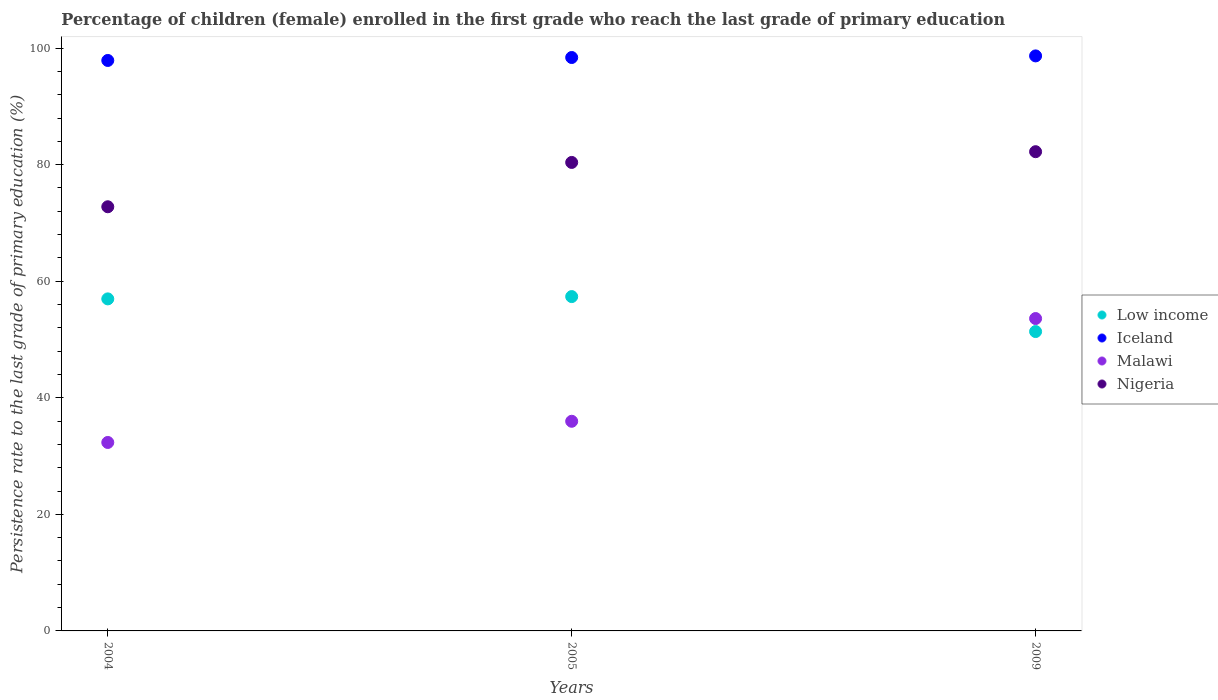How many different coloured dotlines are there?
Keep it short and to the point. 4. Is the number of dotlines equal to the number of legend labels?
Ensure brevity in your answer.  Yes. What is the persistence rate of children in Iceland in 2009?
Ensure brevity in your answer.  98.65. Across all years, what is the maximum persistence rate of children in Iceland?
Offer a very short reply. 98.65. Across all years, what is the minimum persistence rate of children in Malawi?
Your answer should be very brief. 32.33. In which year was the persistence rate of children in Malawi maximum?
Your answer should be compact. 2009. In which year was the persistence rate of children in Low income minimum?
Your answer should be compact. 2009. What is the total persistence rate of children in Low income in the graph?
Offer a terse response. 165.69. What is the difference between the persistence rate of children in Malawi in 2004 and that in 2005?
Your answer should be compact. -3.63. What is the difference between the persistence rate of children in Low income in 2005 and the persistence rate of children in Malawi in 2009?
Ensure brevity in your answer.  3.77. What is the average persistence rate of children in Low income per year?
Provide a succinct answer. 55.23. In the year 2004, what is the difference between the persistence rate of children in Low income and persistence rate of children in Iceland?
Give a very brief answer. -40.91. In how many years, is the persistence rate of children in Low income greater than 36 %?
Provide a short and direct response. 3. What is the ratio of the persistence rate of children in Iceland in 2004 to that in 2009?
Your response must be concise. 0.99. Is the persistence rate of children in Low income in 2004 less than that in 2005?
Your answer should be very brief. Yes. Is the difference between the persistence rate of children in Low income in 2004 and 2009 greater than the difference between the persistence rate of children in Iceland in 2004 and 2009?
Offer a very short reply. Yes. What is the difference between the highest and the second highest persistence rate of children in Iceland?
Ensure brevity in your answer.  0.27. What is the difference between the highest and the lowest persistence rate of children in Nigeria?
Keep it short and to the point. 9.45. In how many years, is the persistence rate of children in Low income greater than the average persistence rate of children in Low income taken over all years?
Keep it short and to the point. 2. Is it the case that in every year, the sum of the persistence rate of children in Iceland and persistence rate of children in Low income  is greater than the sum of persistence rate of children in Nigeria and persistence rate of children in Malawi?
Provide a short and direct response. No. Is the persistence rate of children in Low income strictly greater than the persistence rate of children in Malawi over the years?
Your answer should be compact. No. Is the persistence rate of children in Nigeria strictly less than the persistence rate of children in Low income over the years?
Your response must be concise. No. How many years are there in the graph?
Provide a succinct answer. 3. Does the graph contain any zero values?
Provide a succinct answer. No. Does the graph contain grids?
Ensure brevity in your answer.  No. What is the title of the graph?
Your answer should be compact. Percentage of children (female) enrolled in the first grade who reach the last grade of primary education. What is the label or title of the X-axis?
Your answer should be very brief. Years. What is the label or title of the Y-axis?
Keep it short and to the point. Persistence rate to the last grade of primary education (%). What is the Persistence rate to the last grade of primary education (%) of Low income in 2004?
Your response must be concise. 56.97. What is the Persistence rate to the last grade of primary education (%) of Iceland in 2004?
Offer a very short reply. 97.87. What is the Persistence rate to the last grade of primary education (%) in Malawi in 2004?
Your response must be concise. 32.33. What is the Persistence rate to the last grade of primary education (%) of Nigeria in 2004?
Keep it short and to the point. 72.77. What is the Persistence rate to the last grade of primary education (%) of Low income in 2005?
Make the answer very short. 57.36. What is the Persistence rate to the last grade of primary education (%) of Iceland in 2005?
Keep it short and to the point. 98.38. What is the Persistence rate to the last grade of primary education (%) of Malawi in 2005?
Your answer should be compact. 35.97. What is the Persistence rate to the last grade of primary education (%) of Nigeria in 2005?
Ensure brevity in your answer.  80.38. What is the Persistence rate to the last grade of primary education (%) in Low income in 2009?
Ensure brevity in your answer.  51.36. What is the Persistence rate to the last grade of primary education (%) in Iceland in 2009?
Make the answer very short. 98.65. What is the Persistence rate to the last grade of primary education (%) in Malawi in 2009?
Your response must be concise. 53.59. What is the Persistence rate to the last grade of primary education (%) of Nigeria in 2009?
Make the answer very short. 82.22. Across all years, what is the maximum Persistence rate to the last grade of primary education (%) of Low income?
Offer a very short reply. 57.36. Across all years, what is the maximum Persistence rate to the last grade of primary education (%) in Iceland?
Your answer should be very brief. 98.65. Across all years, what is the maximum Persistence rate to the last grade of primary education (%) of Malawi?
Keep it short and to the point. 53.59. Across all years, what is the maximum Persistence rate to the last grade of primary education (%) in Nigeria?
Ensure brevity in your answer.  82.22. Across all years, what is the minimum Persistence rate to the last grade of primary education (%) in Low income?
Your response must be concise. 51.36. Across all years, what is the minimum Persistence rate to the last grade of primary education (%) of Iceland?
Ensure brevity in your answer.  97.87. Across all years, what is the minimum Persistence rate to the last grade of primary education (%) of Malawi?
Your answer should be compact. 32.33. Across all years, what is the minimum Persistence rate to the last grade of primary education (%) in Nigeria?
Your answer should be very brief. 72.77. What is the total Persistence rate to the last grade of primary education (%) in Low income in the graph?
Your answer should be compact. 165.69. What is the total Persistence rate to the last grade of primary education (%) of Iceland in the graph?
Make the answer very short. 294.91. What is the total Persistence rate to the last grade of primary education (%) in Malawi in the graph?
Make the answer very short. 121.9. What is the total Persistence rate to the last grade of primary education (%) in Nigeria in the graph?
Offer a very short reply. 235.37. What is the difference between the Persistence rate to the last grade of primary education (%) in Low income in 2004 and that in 2005?
Your answer should be compact. -0.39. What is the difference between the Persistence rate to the last grade of primary education (%) of Iceland in 2004 and that in 2005?
Offer a very short reply. -0.51. What is the difference between the Persistence rate to the last grade of primary education (%) of Malawi in 2004 and that in 2005?
Give a very brief answer. -3.63. What is the difference between the Persistence rate to the last grade of primary education (%) in Nigeria in 2004 and that in 2005?
Offer a very short reply. -7.61. What is the difference between the Persistence rate to the last grade of primary education (%) of Low income in 2004 and that in 2009?
Provide a succinct answer. 5.61. What is the difference between the Persistence rate to the last grade of primary education (%) of Iceland in 2004 and that in 2009?
Offer a terse response. -0.78. What is the difference between the Persistence rate to the last grade of primary education (%) in Malawi in 2004 and that in 2009?
Offer a very short reply. -21.26. What is the difference between the Persistence rate to the last grade of primary education (%) in Nigeria in 2004 and that in 2009?
Keep it short and to the point. -9.45. What is the difference between the Persistence rate to the last grade of primary education (%) in Low income in 2005 and that in 2009?
Your answer should be compact. 6. What is the difference between the Persistence rate to the last grade of primary education (%) in Iceland in 2005 and that in 2009?
Your response must be concise. -0.27. What is the difference between the Persistence rate to the last grade of primary education (%) in Malawi in 2005 and that in 2009?
Offer a terse response. -17.63. What is the difference between the Persistence rate to the last grade of primary education (%) in Nigeria in 2005 and that in 2009?
Offer a terse response. -1.84. What is the difference between the Persistence rate to the last grade of primary education (%) of Low income in 2004 and the Persistence rate to the last grade of primary education (%) of Iceland in 2005?
Your response must be concise. -41.41. What is the difference between the Persistence rate to the last grade of primary education (%) of Low income in 2004 and the Persistence rate to the last grade of primary education (%) of Malawi in 2005?
Keep it short and to the point. 21. What is the difference between the Persistence rate to the last grade of primary education (%) of Low income in 2004 and the Persistence rate to the last grade of primary education (%) of Nigeria in 2005?
Make the answer very short. -23.41. What is the difference between the Persistence rate to the last grade of primary education (%) in Iceland in 2004 and the Persistence rate to the last grade of primary education (%) in Malawi in 2005?
Provide a succinct answer. 61.9. What is the difference between the Persistence rate to the last grade of primary education (%) of Iceland in 2004 and the Persistence rate to the last grade of primary education (%) of Nigeria in 2005?
Offer a terse response. 17.5. What is the difference between the Persistence rate to the last grade of primary education (%) in Malawi in 2004 and the Persistence rate to the last grade of primary education (%) in Nigeria in 2005?
Give a very brief answer. -48.04. What is the difference between the Persistence rate to the last grade of primary education (%) of Low income in 2004 and the Persistence rate to the last grade of primary education (%) of Iceland in 2009?
Provide a short and direct response. -41.69. What is the difference between the Persistence rate to the last grade of primary education (%) of Low income in 2004 and the Persistence rate to the last grade of primary education (%) of Malawi in 2009?
Provide a short and direct response. 3.37. What is the difference between the Persistence rate to the last grade of primary education (%) in Low income in 2004 and the Persistence rate to the last grade of primary education (%) in Nigeria in 2009?
Provide a succinct answer. -25.25. What is the difference between the Persistence rate to the last grade of primary education (%) in Iceland in 2004 and the Persistence rate to the last grade of primary education (%) in Malawi in 2009?
Offer a terse response. 44.28. What is the difference between the Persistence rate to the last grade of primary education (%) of Iceland in 2004 and the Persistence rate to the last grade of primary education (%) of Nigeria in 2009?
Offer a very short reply. 15.65. What is the difference between the Persistence rate to the last grade of primary education (%) of Malawi in 2004 and the Persistence rate to the last grade of primary education (%) of Nigeria in 2009?
Give a very brief answer. -49.89. What is the difference between the Persistence rate to the last grade of primary education (%) of Low income in 2005 and the Persistence rate to the last grade of primary education (%) of Iceland in 2009?
Keep it short and to the point. -41.29. What is the difference between the Persistence rate to the last grade of primary education (%) of Low income in 2005 and the Persistence rate to the last grade of primary education (%) of Malawi in 2009?
Keep it short and to the point. 3.77. What is the difference between the Persistence rate to the last grade of primary education (%) in Low income in 2005 and the Persistence rate to the last grade of primary education (%) in Nigeria in 2009?
Your answer should be very brief. -24.86. What is the difference between the Persistence rate to the last grade of primary education (%) of Iceland in 2005 and the Persistence rate to the last grade of primary education (%) of Malawi in 2009?
Provide a succinct answer. 44.78. What is the difference between the Persistence rate to the last grade of primary education (%) of Iceland in 2005 and the Persistence rate to the last grade of primary education (%) of Nigeria in 2009?
Your answer should be compact. 16.16. What is the difference between the Persistence rate to the last grade of primary education (%) of Malawi in 2005 and the Persistence rate to the last grade of primary education (%) of Nigeria in 2009?
Your answer should be compact. -46.25. What is the average Persistence rate to the last grade of primary education (%) in Low income per year?
Your response must be concise. 55.23. What is the average Persistence rate to the last grade of primary education (%) of Iceland per year?
Offer a very short reply. 98.3. What is the average Persistence rate to the last grade of primary education (%) of Malawi per year?
Your answer should be compact. 40.63. What is the average Persistence rate to the last grade of primary education (%) of Nigeria per year?
Provide a succinct answer. 78.46. In the year 2004, what is the difference between the Persistence rate to the last grade of primary education (%) in Low income and Persistence rate to the last grade of primary education (%) in Iceland?
Give a very brief answer. -40.91. In the year 2004, what is the difference between the Persistence rate to the last grade of primary education (%) of Low income and Persistence rate to the last grade of primary education (%) of Malawi?
Provide a short and direct response. 24.63. In the year 2004, what is the difference between the Persistence rate to the last grade of primary education (%) in Low income and Persistence rate to the last grade of primary education (%) in Nigeria?
Ensure brevity in your answer.  -15.8. In the year 2004, what is the difference between the Persistence rate to the last grade of primary education (%) of Iceland and Persistence rate to the last grade of primary education (%) of Malawi?
Your answer should be very brief. 65.54. In the year 2004, what is the difference between the Persistence rate to the last grade of primary education (%) in Iceland and Persistence rate to the last grade of primary education (%) in Nigeria?
Your answer should be very brief. 25.1. In the year 2004, what is the difference between the Persistence rate to the last grade of primary education (%) of Malawi and Persistence rate to the last grade of primary education (%) of Nigeria?
Provide a succinct answer. -40.44. In the year 2005, what is the difference between the Persistence rate to the last grade of primary education (%) in Low income and Persistence rate to the last grade of primary education (%) in Iceland?
Make the answer very short. -41.02. In the year 2005, what is the difference between the Persistence rate to the last grade of primary education (%) of Low income and Persistence rate to the last grade of primary education (%) of Malawi?
Ensure brevity in your answer.  21.39. In the year 2005, what is the difference between the Persistence rate to the last grade of primary education (%) of Low income and Persistence rate to the last grade of primary education (%) of Nigeria?
Keep it short and to the point. -23.02. In the year 2005, what is the difference between the Persistence rate to the last grade of primary education (%) in Iceland and Persistence rate to the last grade of primary education (%) in Malawi?
Provide a succinct answer. 62.41. In the year 2005, what is the difference between the Persistence rate to the last grade of primary education (%) in Iceland and Persistence rate to the last grade of primary education (%) in Nigeria?
Keep it short and to the point. 18. In the year 2005, what is the difference between the Persistence rate to the last grade of primary education (%) of Malawi and Persistence rate to the last grade of primary education (%) of Nigeria?
Offer a terse response. -44.41. In the year 2009, what is the difference between the Persistence rate to the last grade of primary education (%) in Low income and Persistence rate to the last grade of primary education (%) in Iceland?
Provide a short and direct response. -47.29. In the year 2009, what is the difference between the Persistence rate to the last grade of primary education (%) of Low income and Persistence rate to the last grade of primary education (%) of Malawi?
Your answer should be very brief. -2.23. In the year 2009, what is the difference between the Persistence rate to the last grade of primary education (%) in Low income and Persistence rate to the last grade of primary education (%) in Nigeria?
Your answer should be compact. -30.86. In the year 2009, what is the difference between the Persistence rate to the last grade of primary education (%) of Iceland and Persistence rate to the last grade of primary education (%) of Malawi?
Make the answer very short. 45.06. In the year 2009, what is the difference between the Persistence rate to the last grade of primary education (%) in Iceland and Persistence rate to the last grade of primary education (%) in Nigeria?
Make the answer very short. 16.43. In the year 2009, what is the difference between the Persistence rate to the last grade of primary education (%) in Malawi and Persistence rate to the last grade of primary education (%) in Nigeria?
Provide a short and direct response. -28.63. What is the ratio of the Persistence rate to the last grade of primary education (%) of Low income in 2004 to that in 2005?
Offer a terse response. 0.99. What is the ratio of the Persistence rate to the last grade of primary education (%) of Iceland in 2004 to that in 2005?
Offer a terse response. 0.99. What is the ratio of the Persistence rate to the last grade of primary education (%) in Malawi in 2004 to that in 2005?
Provide a short and direct response. 0.9. What is the ratio of the Persistence rate to the last grade of primary education (%) of Nigeria in 2004 to that in 2005?
Your answer should be compact. 0.91. What is the ratio of the Persistence rate to the last grade of primary education (%) of Low income in 2004 to that in 2009?
Your response must be concise. 1.11. What is the ratio of the Persistence rate to the last grade of primary education (%) of Iceland in 2004 to that in 2009?
Provide a succinct answer. 0.99. What is the ratio of the Persistence rate to the last grade of primary education (%) in Malawi in 2004 to that in 2009?
Provide a short and direct response. 0.6. What is the ratio of the Persistence rate to the last grade of primary education (%) in Nigeria in 2004 to that in 2009?
Your answer should be compact. 0.89. What is the ratio of the Persistence rate to the last grade of primary education (%) of Low income in 2005 to that in 2009?
Provide a succinct answer. 1.12. What is the ratio of the Persistence rate to the last grade of primary education (%) in Malawi in 2005 to that in 2009?
Offer a terse response. 0.67. What is the ratio of the Persistence rate to the last grade of primary education (%) of Nigeria in 2005 to that in 2009?
Your answer should be compact. 0.98. What is the difference between the highest and the second highest Persistence rate to the last grade of primary education (%) in Low income?
Offer a terse response. 0.39. What is the difference between the highest and the second highest Persistence rate to the last grade of primary education (%) of Iceland?
Offer a very short reply. 0.27. What is the difference between the highest and the second highest Persistence rate to the last grade of primary education (%) in Malawi?
Provide a short and direct response. 17.63. What is the difference between the highest and the second highest Persistence rate to the last grade of primary education (%) in Nigeria?
Keep it short and to the point. 1.84. What is the difference between the highest and the lowest Persistence rate to the last grade of primary education (%) in Low income?
Ensure brevity in your answer.  6. What is the difference between the highest and the lowest Persistence rate to the last grade of primary education (%) of Iceland?
Your answer should be compact. 0.78. What is the difference between the highest and the lowest Persistence rate to the last grade of primary education (%) in Malawi?
Your answer should be compact. 21.26. What is the difference between the highest and the lowest Persistence rate to the last grade of primary education (%) of Nigeria?
Make the answer very short. 9.45. 